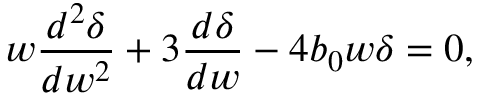Convert formula to latex. <formula><loc_0><loc_0><loc_500><loc_500>w \frac { d ^ { 2 } \delta } { d w ^ { 2 } } + 3 \frac { d \delta } { d w } - 4 b _ { 0 } w \delta = 0 ,</formula> 